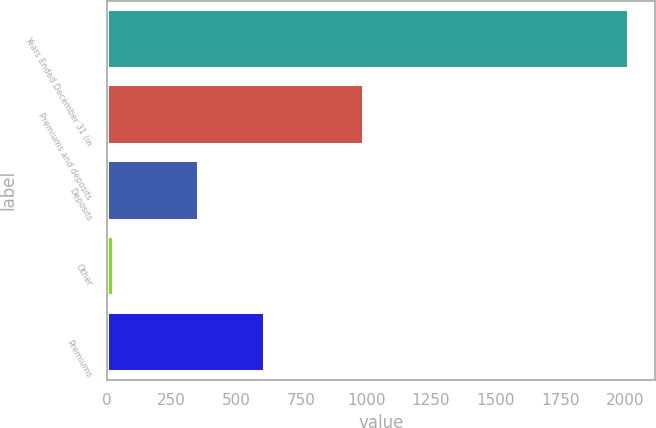<chart> <loc_0><loc_0><loc_500><loc_500><bar_chart><fcel>Years Ended December 31 (in<fcel>Premiums and deposits<fcel>Deposits<fcel>Other<fcel>Premiums<nl><fcel>2013<fcel>991<fcel>354<fcel>27<fcel>610<nl></chart> 